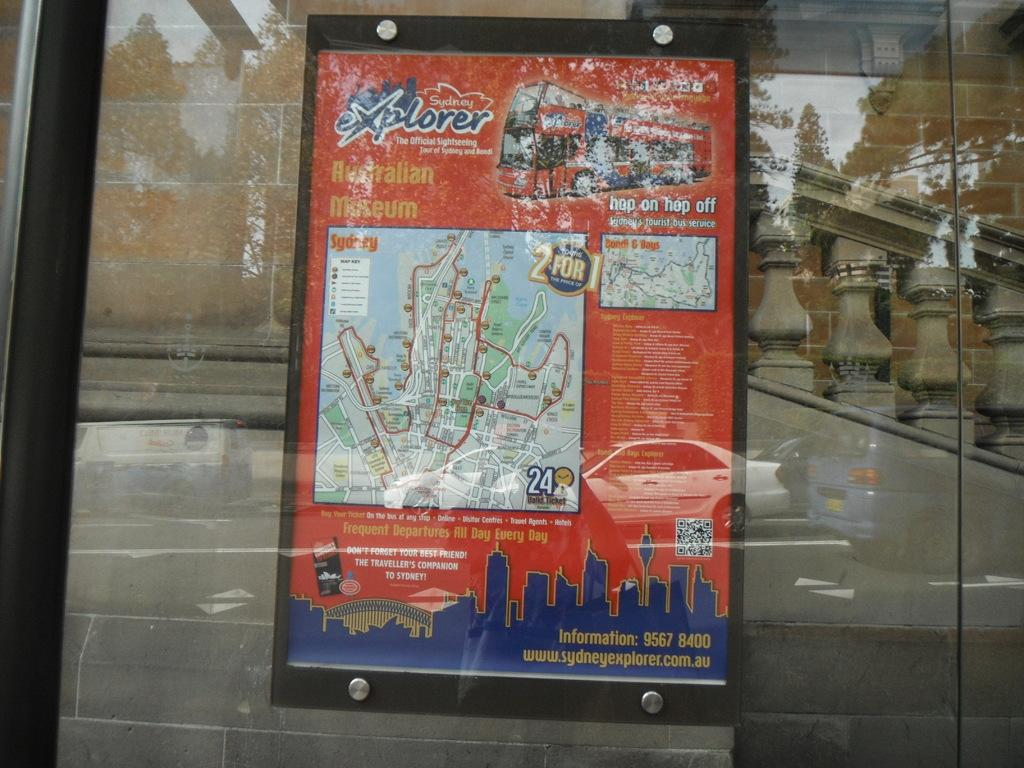<image>
Create a compact narrative representing the image presented. A sightseeing poster and map for the Sydney Explorer. 